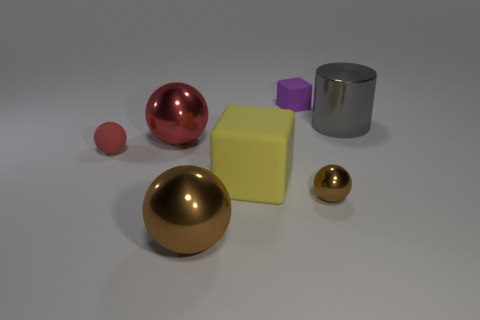Subtract all red matte balls. How many balls are left? 3 Subtract all gray blocks. How many red balls are left? 2 Subtract all brown spheres. How many spheres are left? 2 Subtract all blocks. How many objects are left? 5 Add 1 small yellow matte spheres. How many objects exist? 8 Subtract 3 spheres. How many spheres are left? 1 Add 2 metallic things. How many metallic things are left? 6 Add 1 tiny brown matte blocks. How many tiny brown matte blocks exist? 1 Subtract 0 green cubes. How many objects are left? 7 Subtract all purple cylinders. Subtract all cyan cubes. How many cylinders are left? 1 